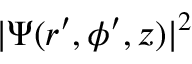Convert formula to latex. <formula><loc_0><loc_0><loc_500><loc_500>| \Psi ( r ^ { \prime } , \phi ^ { \prime } , z ) | ^ { 2 }</formula> 